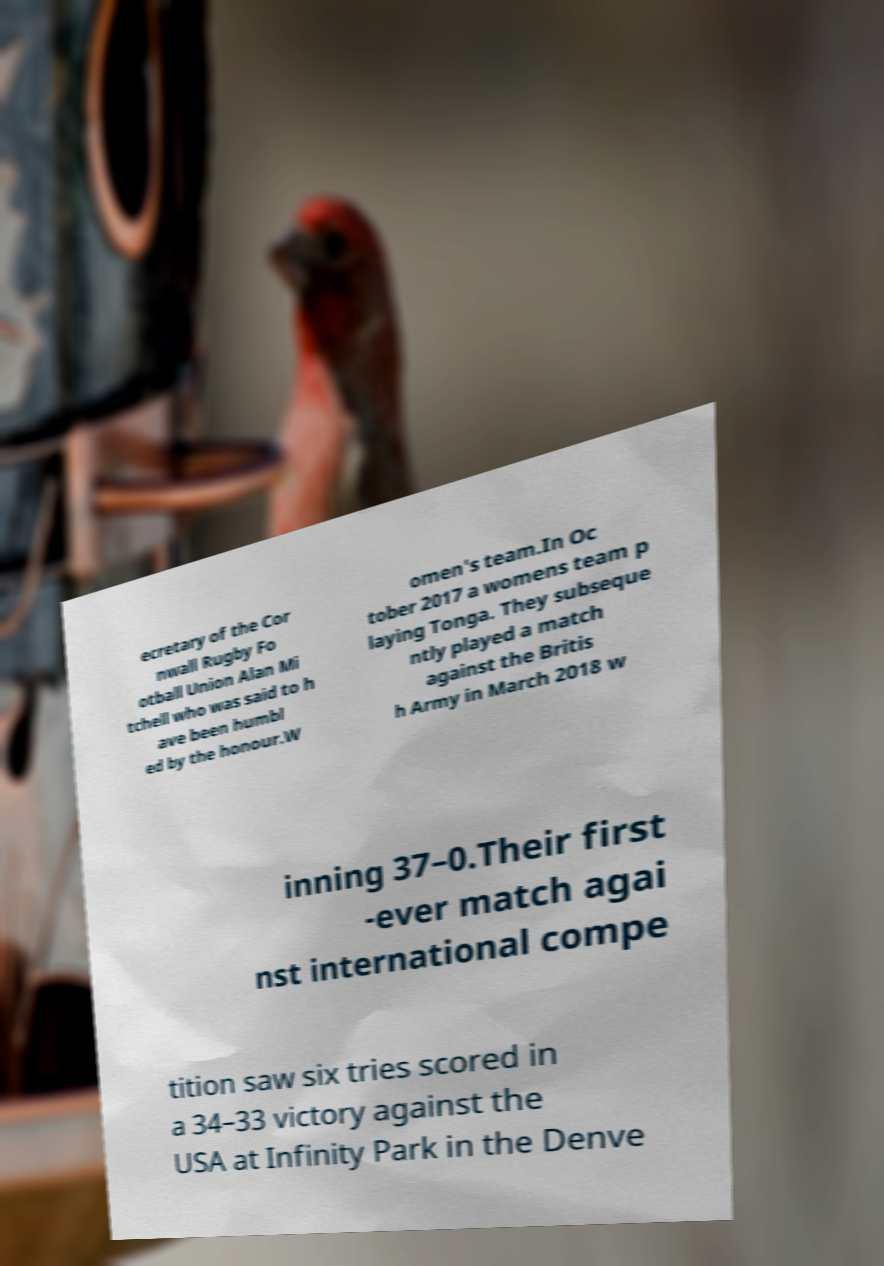Please read and relay the text visible in this image. What does it say? ecretary of the Cor nwall Rugby Fo otball Union Alan Mi tchell who was said to h ave been humbl ed by the honour.W omen's team.In Oc tober 2017 a womens team p laying Tonga. They subseque ntly played a match against the Britis h Army in March 2018 w inning 37–0.Their first -ever match agai nst international compe tition saw six tries scored in a 34–33 victory against the USA at Infinity Park in the Denve 